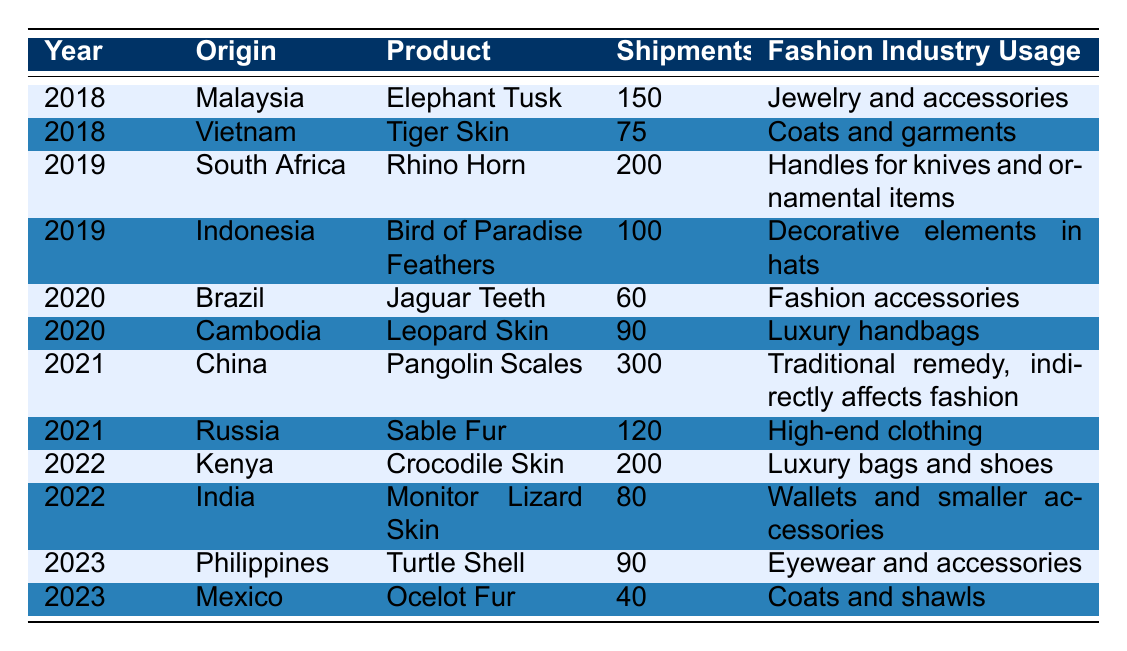What is the total number of shipments from China in 2021? In 2021, there is one entry for China, which shows a total of 300 shipments for Pangolin Scales. Thus, we look directly at that row to find the total.
Answer: 300 Which animal product had the highest total shipments in 2019? In 2019, there are two products: Rhino Horn with 200 shipments and Bird of Paradise Feathers with 100 shipments. Comparing these two numbers, Rhino Horn has the highest total shipments.
Answer: Rhino Horn Is there any product type shipped from Brazil? Looking at the table, there is an entry for Brazil in 2020 that shows Jaguar Teeth as the product type. Thus, there is indeed a product type shipped from Brazil.
Answer: Yes What was the total number of shipments for all products from 2022? For 2022, there are two entries: Crocodile Skin with 200 shipments and Monitor Lizard Skin with 80 shipments. Adding these gives 200 + 80 = 280 shipments. Thus, the total for 2022 is 280.
Answer: 280 Which fashion industry usage is associated with the highest number of shipments in 2021? In 2021, there are two products: Pangolin Scales used as a traditional remedy (with 300 shipments) and Sable Fur used in high-end clothing (with 120 shipments). The highest number is associated with Pangolin Scales.
Answer: Traditional remedy, indirectly affects fashion How many more shipments were made for Elephant Tusk than for Tiger Skin in 2018? In 2018, Elephant Tusk has 150 shipments and Tiger Skin has 75 shipments. The difference in shipments is 150 - 75 = 75 more shipments for Elephant Tusk.
Answer: 75 What is the trend of shipments from 2020 to 2023 in terms of quantity? The shipments from 2020 are 60 (Jaguar Teeth) and 90 (Leopard Skin); total is 150. In 2021, there were 420 shipments (300 for Pangolin Scales and 120 for Sable Fur). In 2022, there were 280 shipments (200 for Crocodile Skin and 80 for Monitor Lizard Skin). In 2023, there are 130 shipments (90 for Turtle Shell and 40 for Ocelot Fur). Comparing these totals (150, 420, 280, 130) indicates that shipments peaked in 2021 and then declined in 2022 and 2023.
Answer: Peak in 2021, then decline What percentage of total shipments in 2021 were accounted for by Pangolin Scales? The total shipments in 2021 were 420 (300 for Pangolin Scales and 120 for Sable Fur). To find the percentage of Pangolin Scales, we calculate (300 / 420) * 100, which gives about 71.43%. Thus, Pangolin Scales account for approximately 71.43% of the shipments in that year.
Answer: 71.43% 